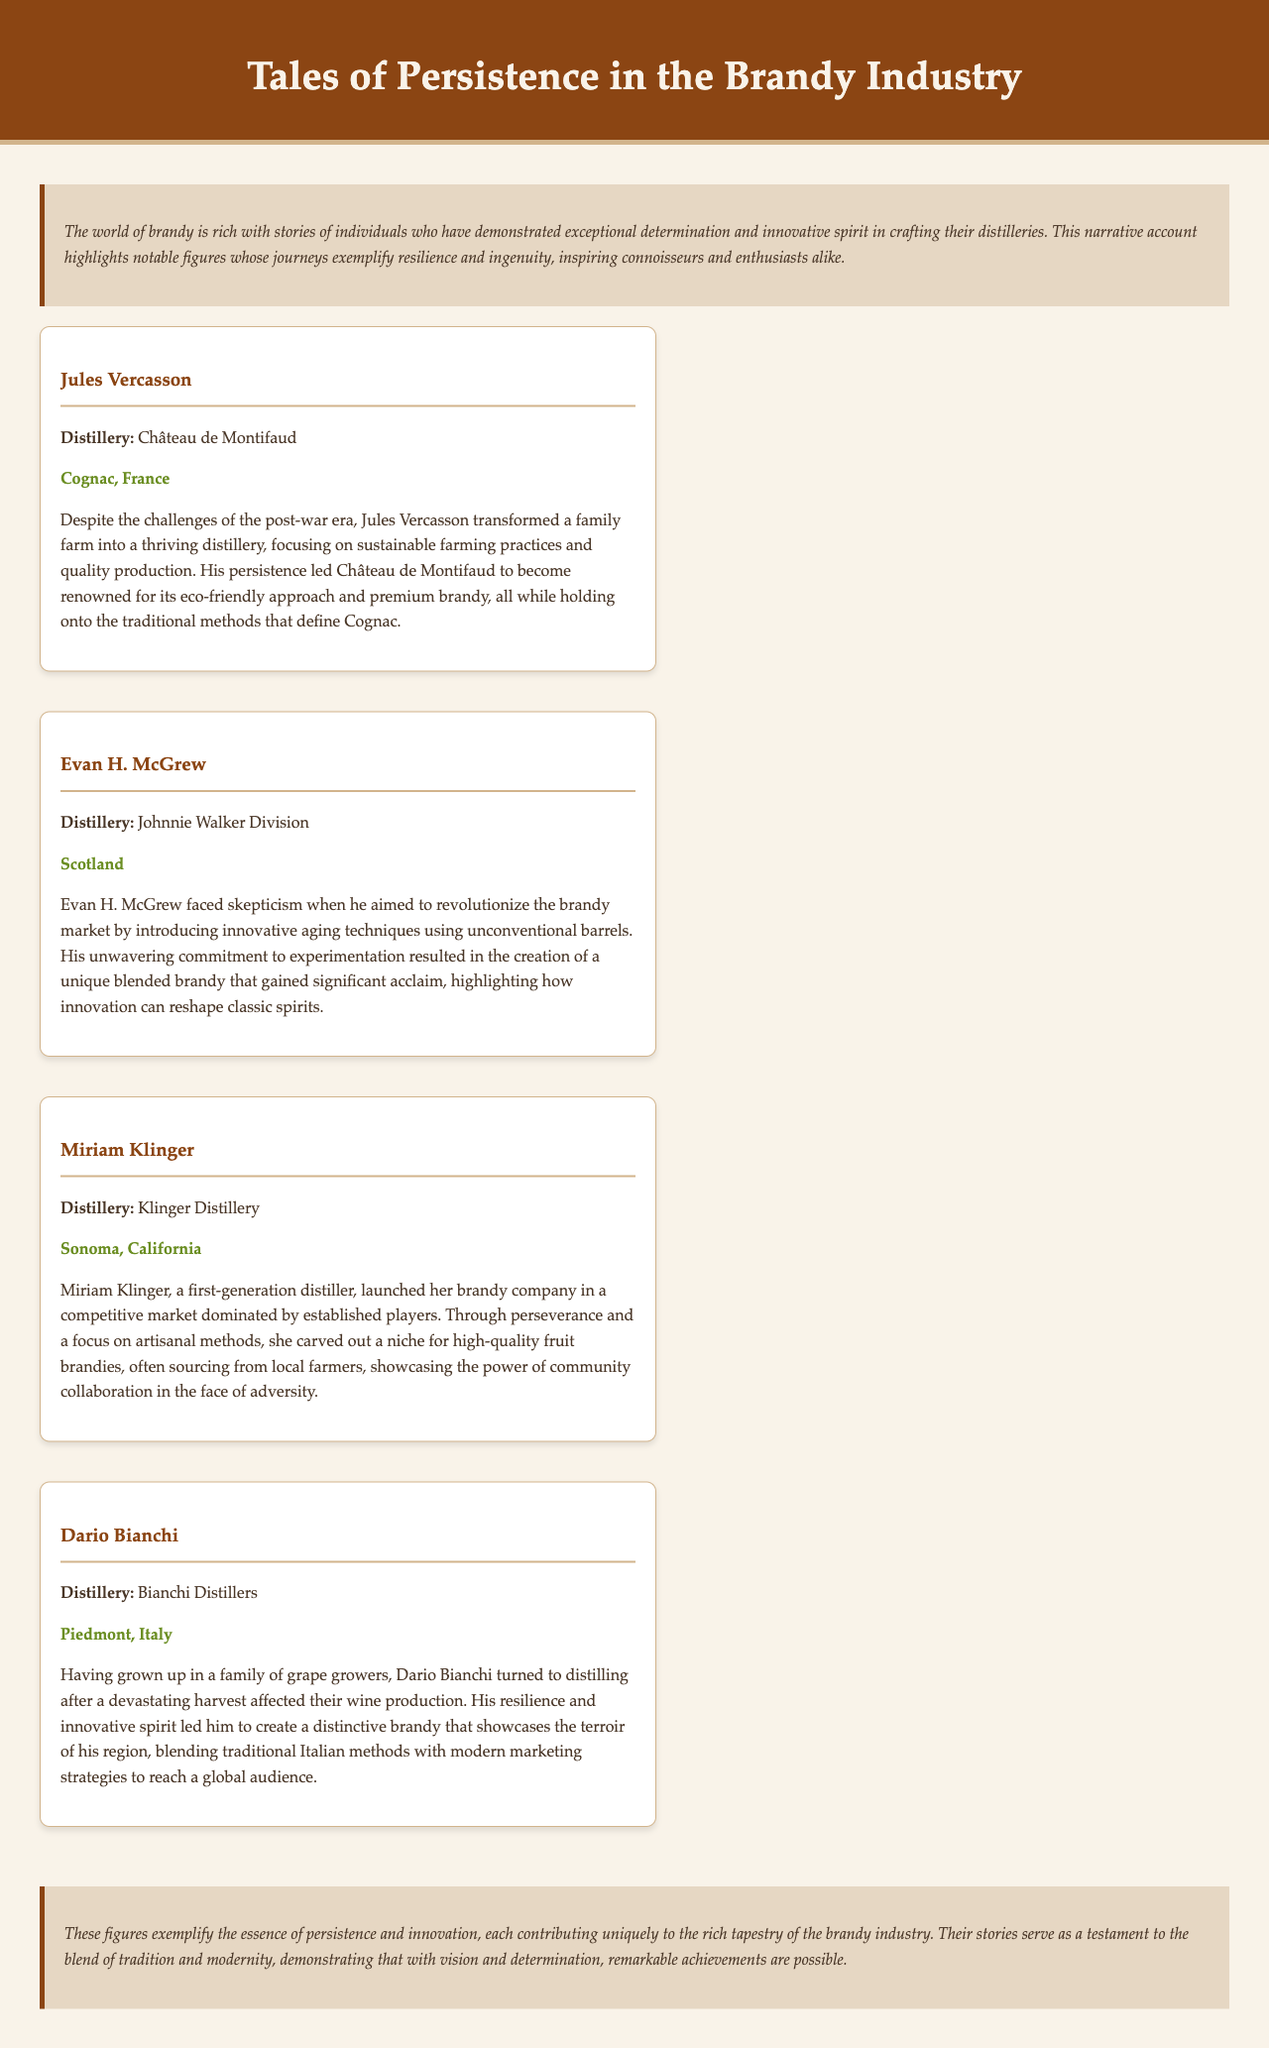What is the title of the document? The title is highlighted in the header section of the document.
Answer: Tales of Persistence in the Brandy Industry Which distillery is associated with Jules Vercasson? The document states the distillery name next to the figure's name.
Answer: Château de Montifaud What innovation did Evan H. McGrew introduce? The document mentions his aim to revolutionize the brandy market with specific techniques.
Answer: Innovative aging techniques Where is the Klinger Distillery located? The location is specified under the name of the distillery in the document.
Answer: Sonoma, California What did Dario Bianchi aim to showcase through his brandy? The document discusses the characteristics Dario wanted to highlight with his product.
Answer: The terroir of his region How did Miriam Klinger differentiate her brandy in the market? The document highlights the strategy she used to carve out a niche for her company.
Answer: Artisanal methods What common theme is present in the stories of these figures? The document concludes with a summary of the essence displayed by these individuals.
Answer: Persistence and innovation 